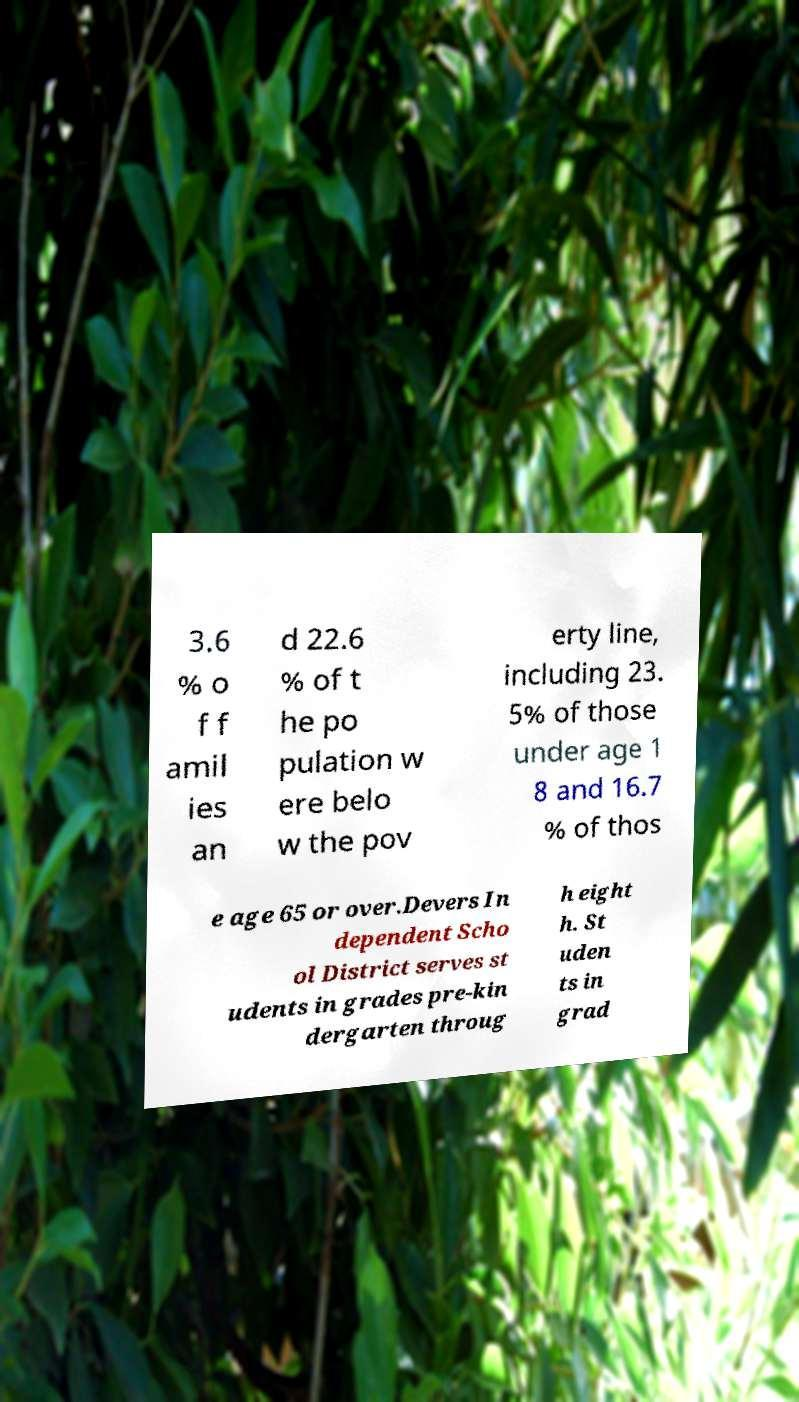There's text embedded in this image that I need extracted. Can you transcribe it verbatim? 3.6 % o f f amil ies an d 22.6 % of t he po pulation w ere belo w the pov erty line, including 23. 5% of those under age 1 8 and 16.7 % of thos e age 65 or over.Devers In dependent Scho ol District serves st udents in grades pre-kin dergarten throug h eight h. St uden ts in grad 